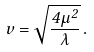Convert formula to latex. <formula><loc_0><loc_0><loc_500><loc_500>v = \sqrt { \frac { 4 \mu ^ { 2 } } { \lambda } } \, .</formula> 